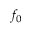Convert formula to latex. <formula><loc_0><loc_0><loc_500><loc_500>f _ { 0 }</formula> 